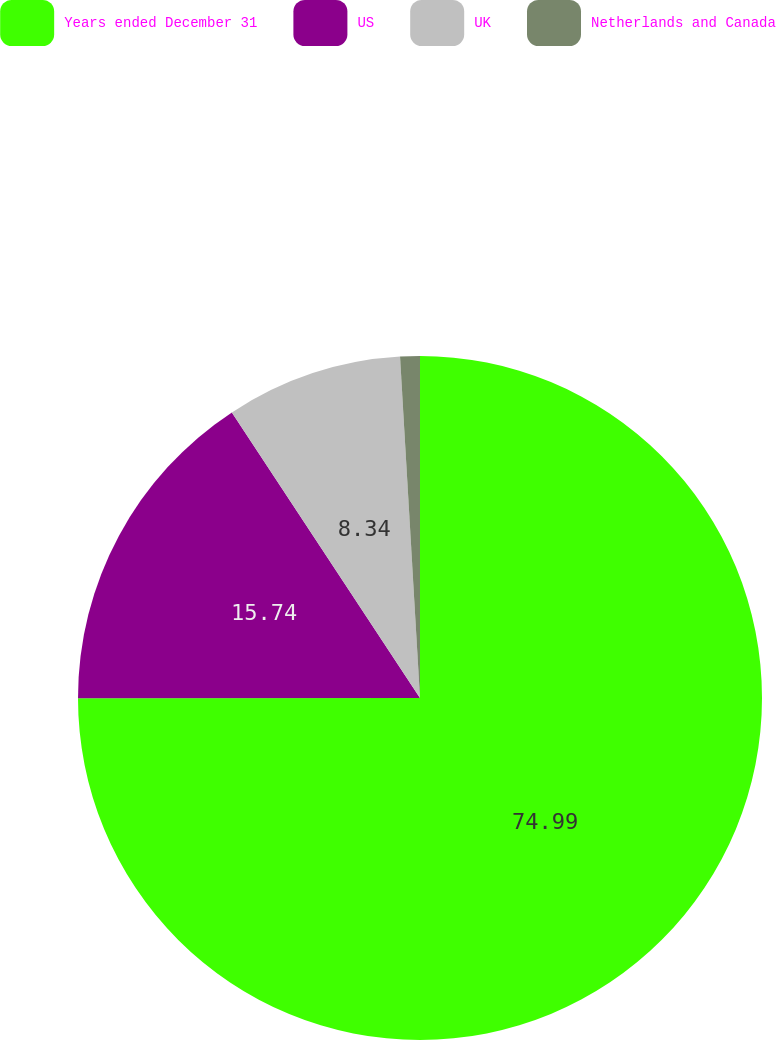Convert chart. <chart><loc_0><loc_0><loc_500><loc_500><pie_chart><fcel>Years ended December 31<fcel>US<fcel>UK<fcel>Netherlands and Canada<nl><fcel>74.99%<fcel>15.74%<fcel>8.34%<fcel>0.93%<nl></chart> 